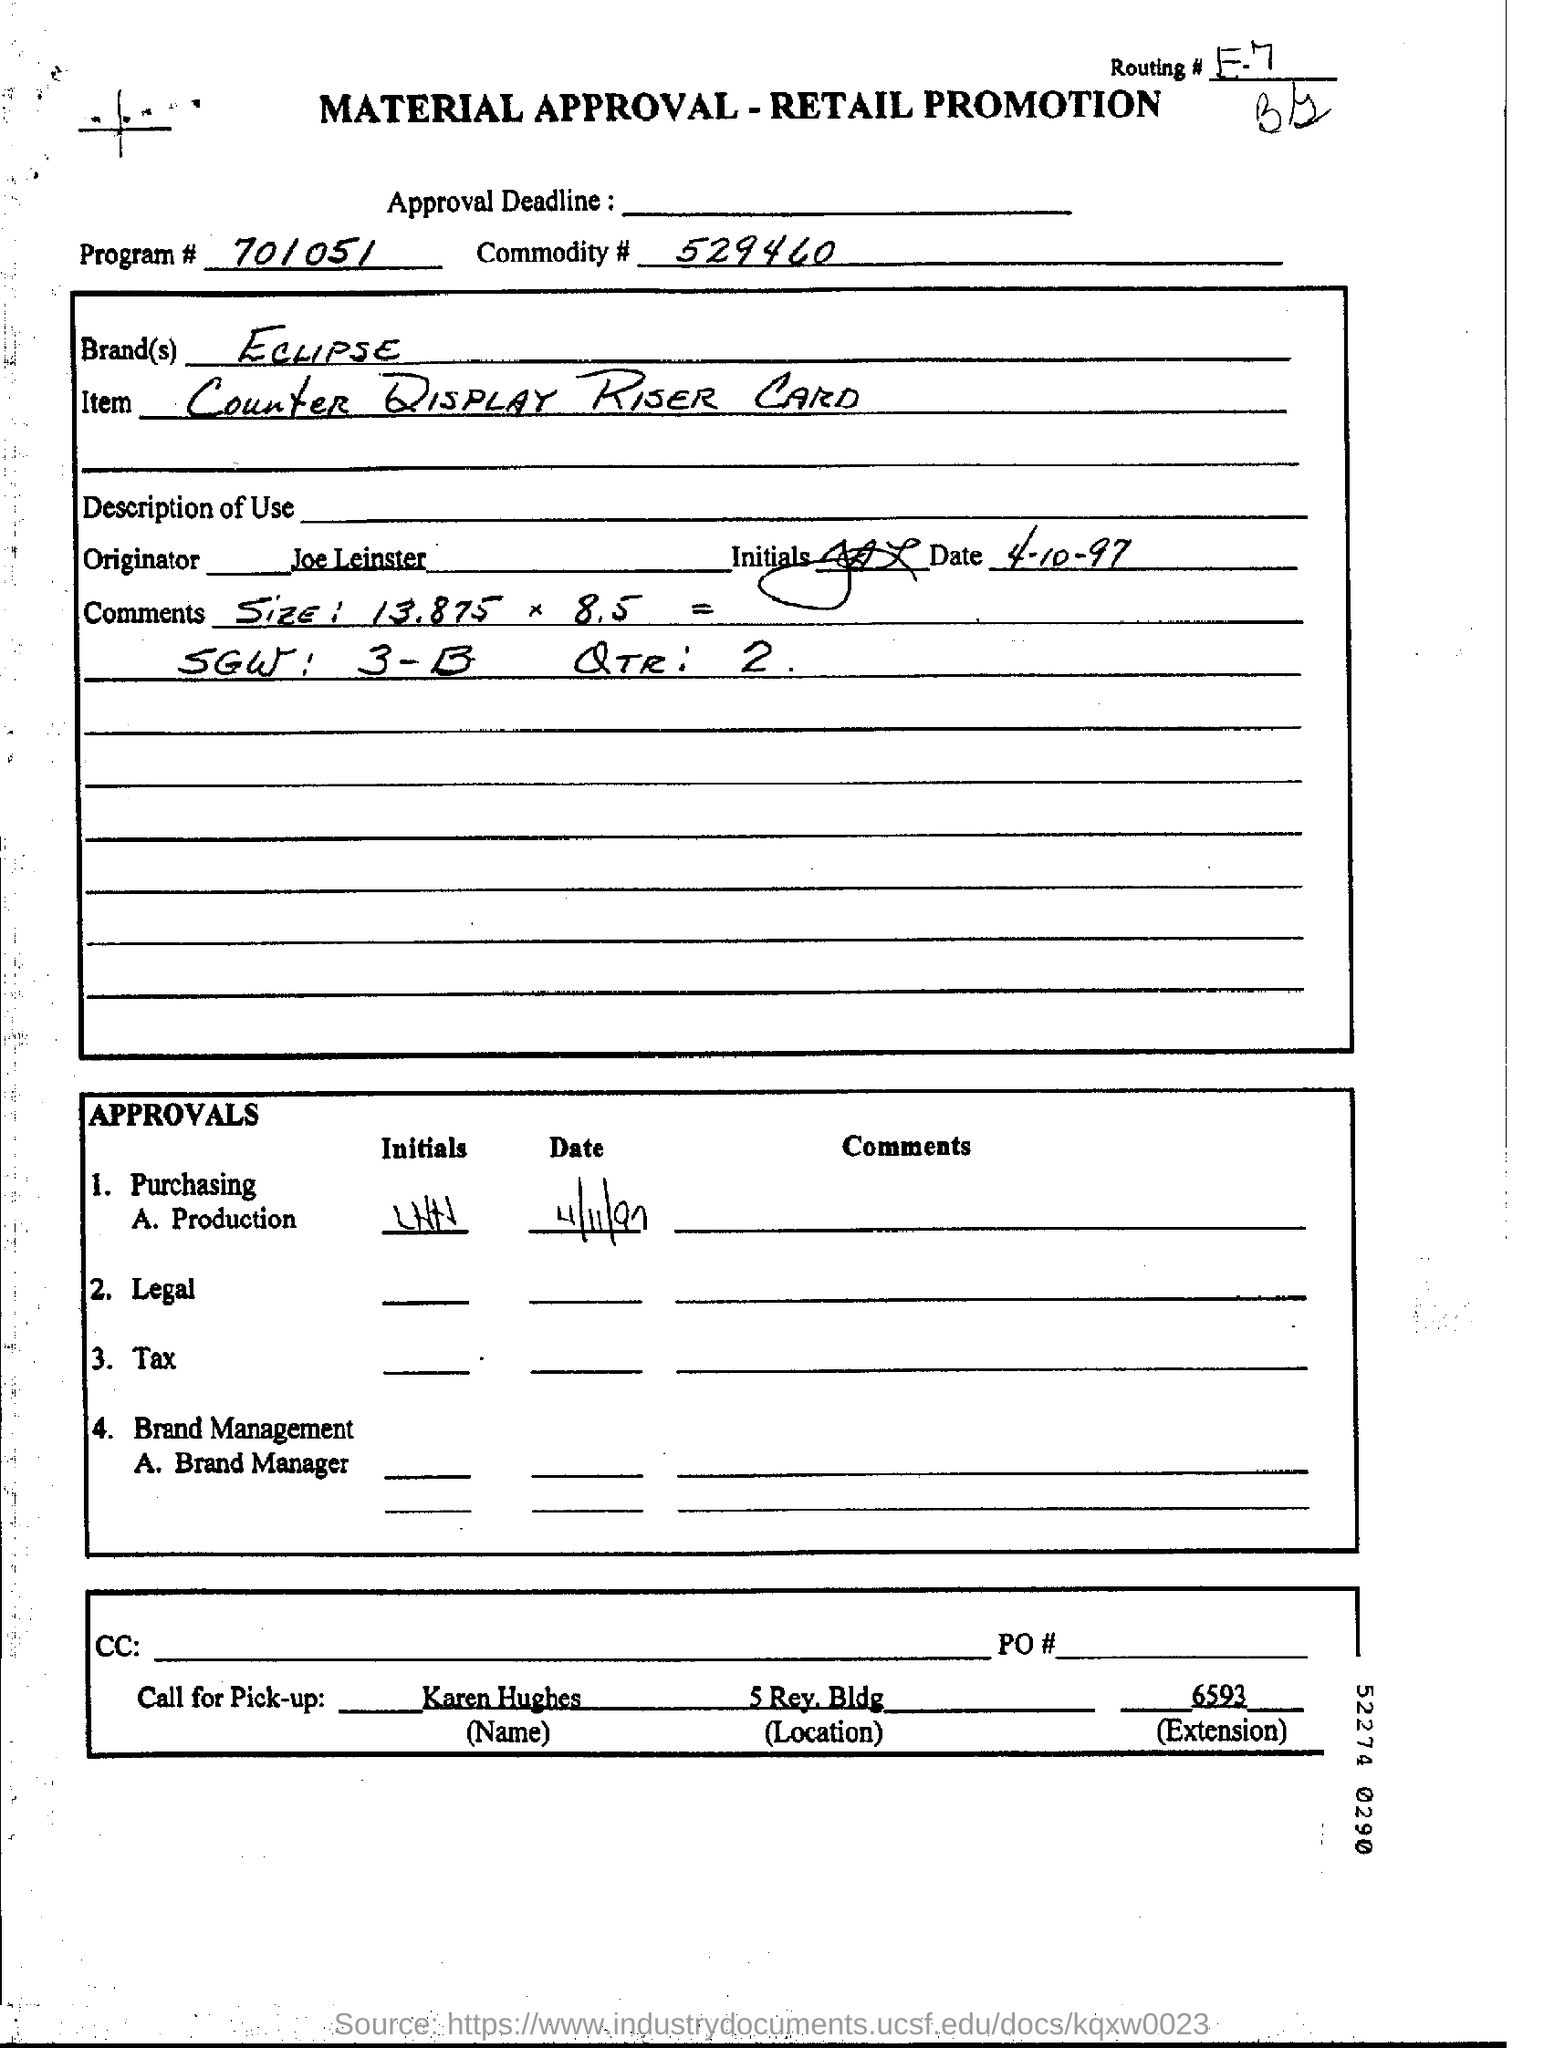Indicate a few pertinent items in this graphic. The originator is Joe Leinster. Karen Hughes should be contacted for pick-up. 